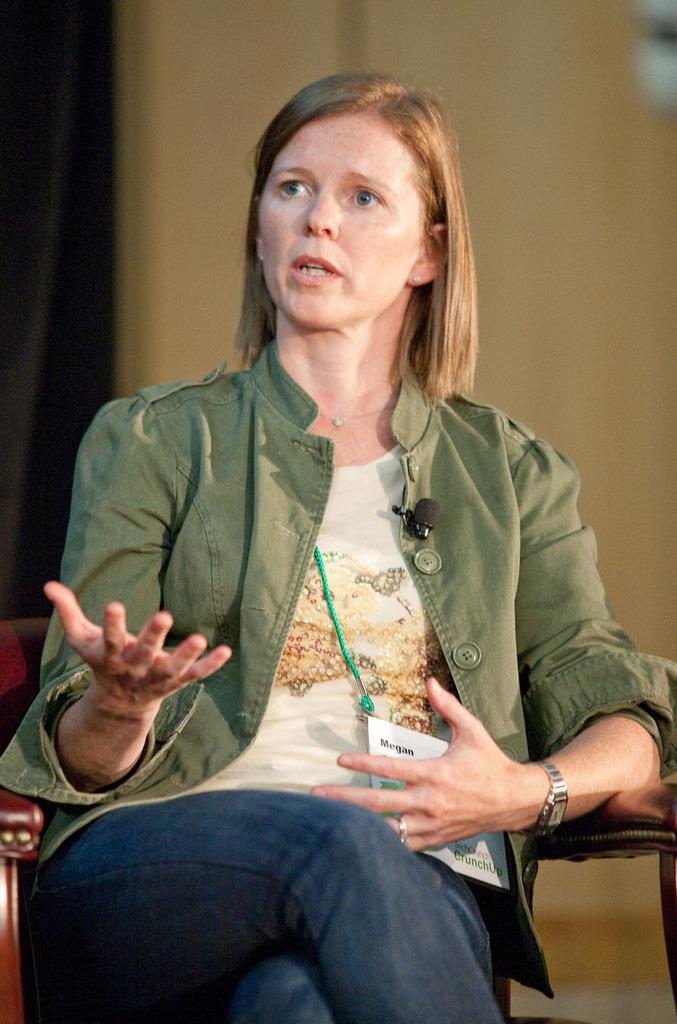Who is the main subject in the image? There is a woman in the image. What is the woman doing in the image? The woman is sitting on a chair and speaking. Can you describe any accessories the woman is wearing? Yes, there is a watch on the woman's left hand. What type of kitty can be seen playing with a frog on the wheel in the image? There is no kitty, frog, or wheel present in the image; it only features a woman sitting on a chair and speaking. 